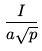<formula> <loc_0><loc_0><loc_500><loc_500>\frac { I } { a { \sqrt { p } } }</formula> 